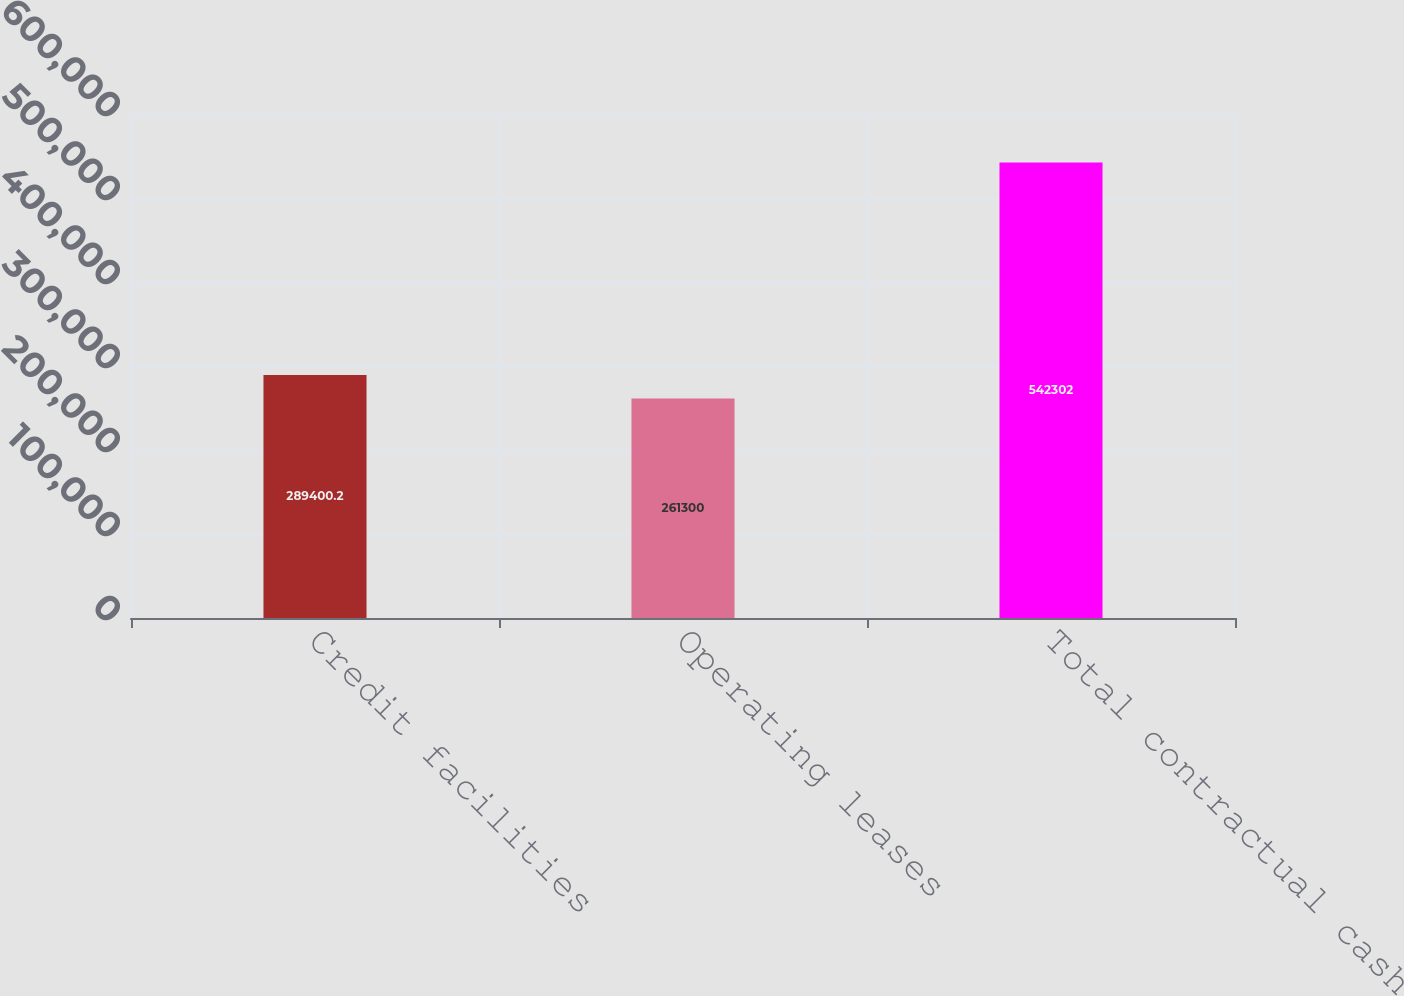<chart> <loc_0><loc_0><loc_500><loc_500><bar_chart><fcel>Credit facilities<fcel>Operating leases<fcel>Total contractual cash<nl><fcel>289400<fcel>261300<fcel>542302<nl></chart> 